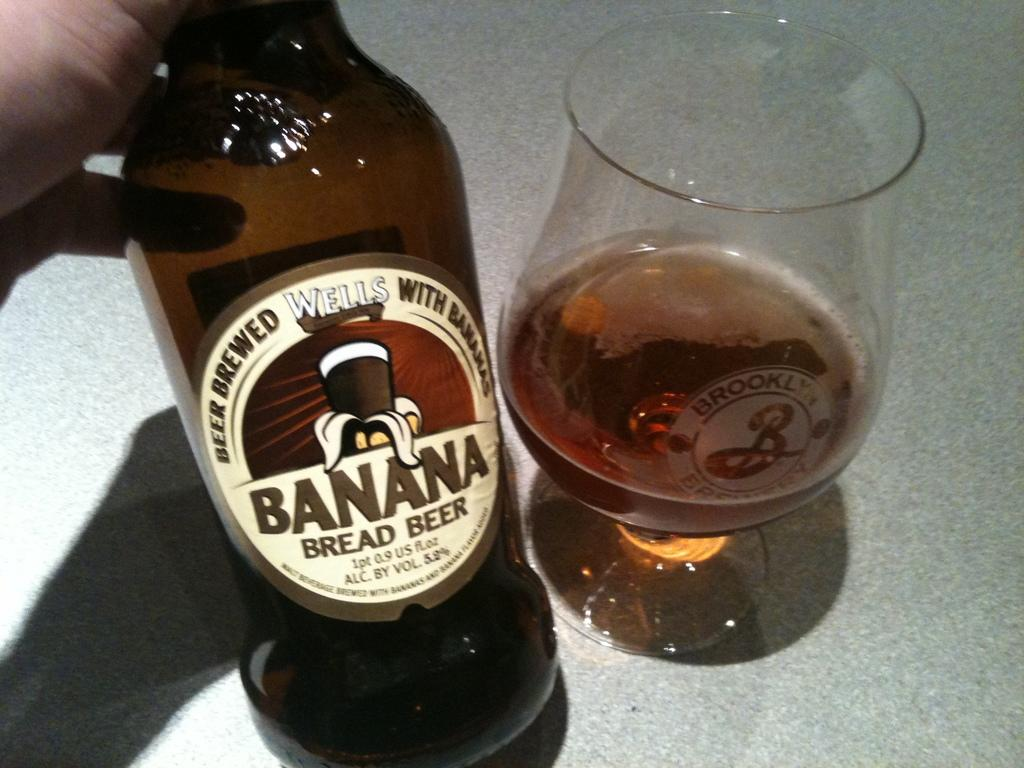Provide a one-sentence caption for the provided image. Person holding a Banana Bread Beer next to an almost empty cup of beer. 